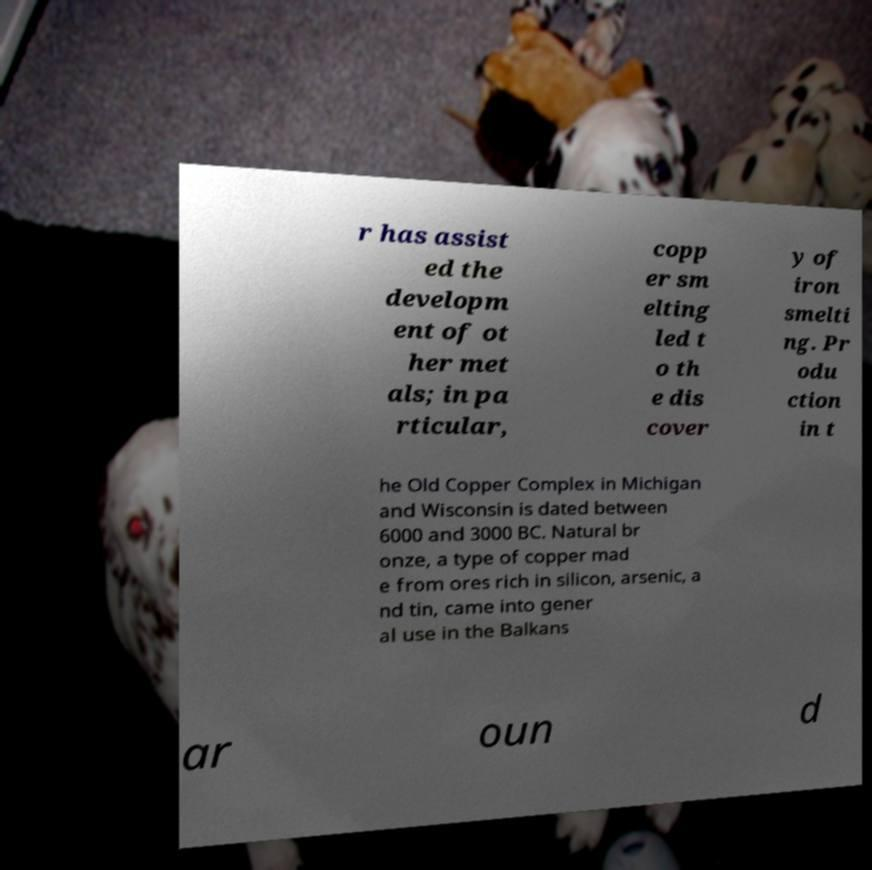Please identify and transcribe the text found in this image. r has assist ed the developm ent of ot her met als; in pa rticular, copp er sm elting led t o th e dis cover y of iron smelti ng. Pr odu ction in t he Old Copper Complex in Michigan and Wisconsin is dated between 6000 and 3000 BC. Natural br onze, a type of copper mad e from ores rich in silicon, arsenic, a nd tin, came into gener al use in the Balkans ar oun d 